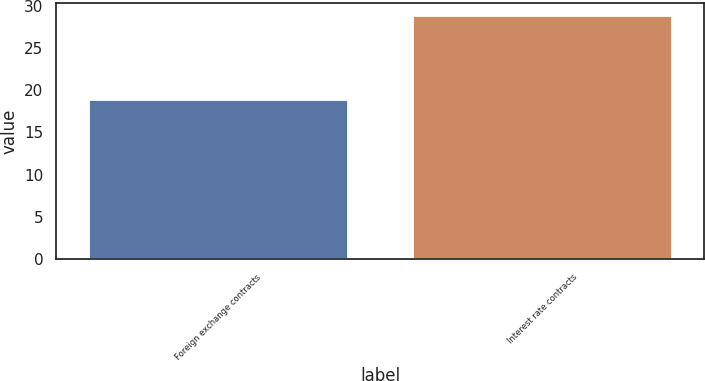Convert chart. <chart><loc_0><loc_0><loc_500><loc_500><bar_chart><fcel>Foreign exchange contracts<fcel>Interest rate contracts<nl><fcel>18.8<fcel>28.8<nl></chart> 